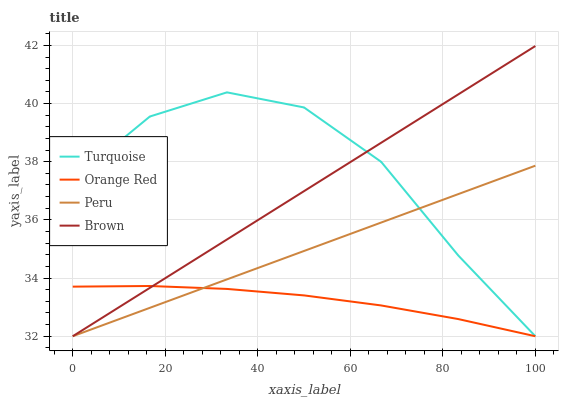Does Orange Red have the minimum area under the curve?
Answer yes or no. Yes. Does Turquoise have the maximum area under the curve?
Answer yes or no. Yes. Does Turquoise have the minimum area under the curve?
Answer yes or no. No. Does Orange Red have the maximum area under the curve?
Answer yes or no. No. Is Peru the smoothest?
Answer yes or no. Yes. Is Turquoise the roughest?
Answer yes or no. Yes. Is Orange Red the smoothest?
Answer yes or no. No. Is Orange Red the roughest?
Answer yes or no. No. Does Brown have the lowest value?
Answer yes or no. Yes. Does Orange Red have the lowest value?
Answer yes or no. No. Does Brown have the highest value?
Answer yes or no. Yes. Does Turquoise have the highest value?
Answer yes or no. No. Does Orange Red intersect Brown?
Answer yes or no. Yes. Is Orange Red less than Brown?
Answer yes or no. No. Is Orange Red greater than Brown?
Answer yes or no. No. 